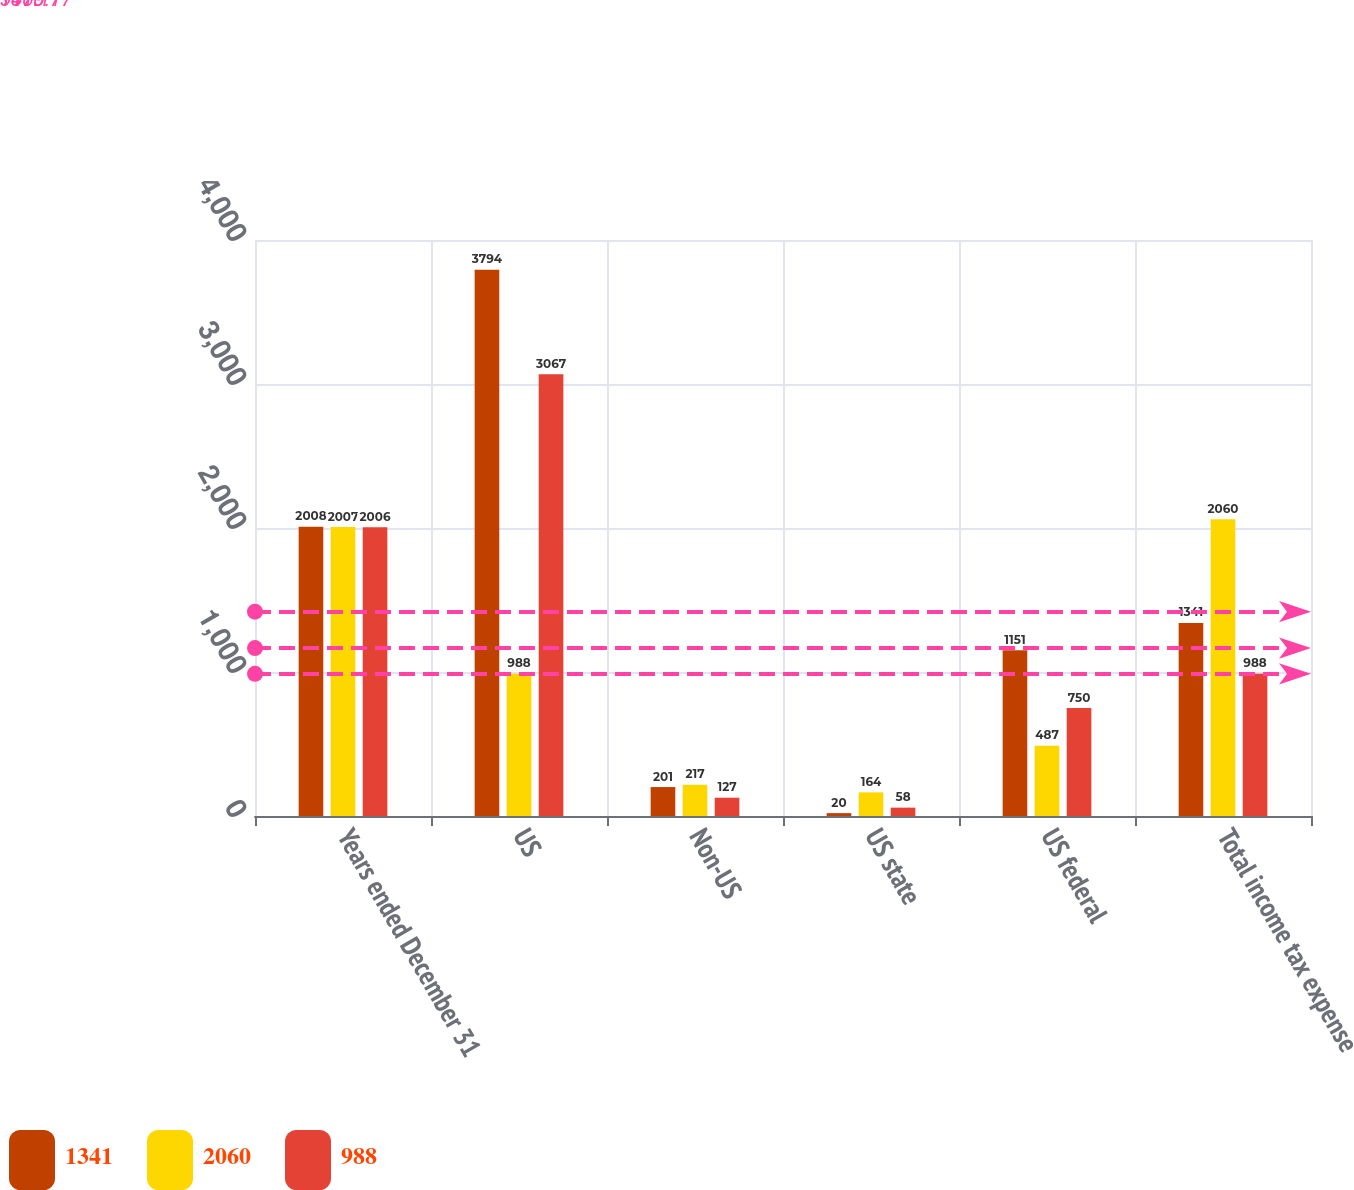Convert chart to OTSL. <chart><loc_0><loc_0><loc_500><loc_500><stacked_bar_chart><ecel><fcel>Years ended December 31<fcel>US<fcel>Non-US<fcel>US state<fcel>US federal<fcel>Total income tax expense<nl><fcel>1341<fcel>2008<fcel>3794<fcel>201<fcel>20<fcel>1151<fcel>1341<nl><fcel>2060<fcel>2007<fcel>988<fcel>217<fcel>164<fcel>487<fcel>2060<nl><fcel>988<fcel>2006<fcel>3067<fcel>127<fcel>58<fcel>750<fcel>988<nl></chart> 